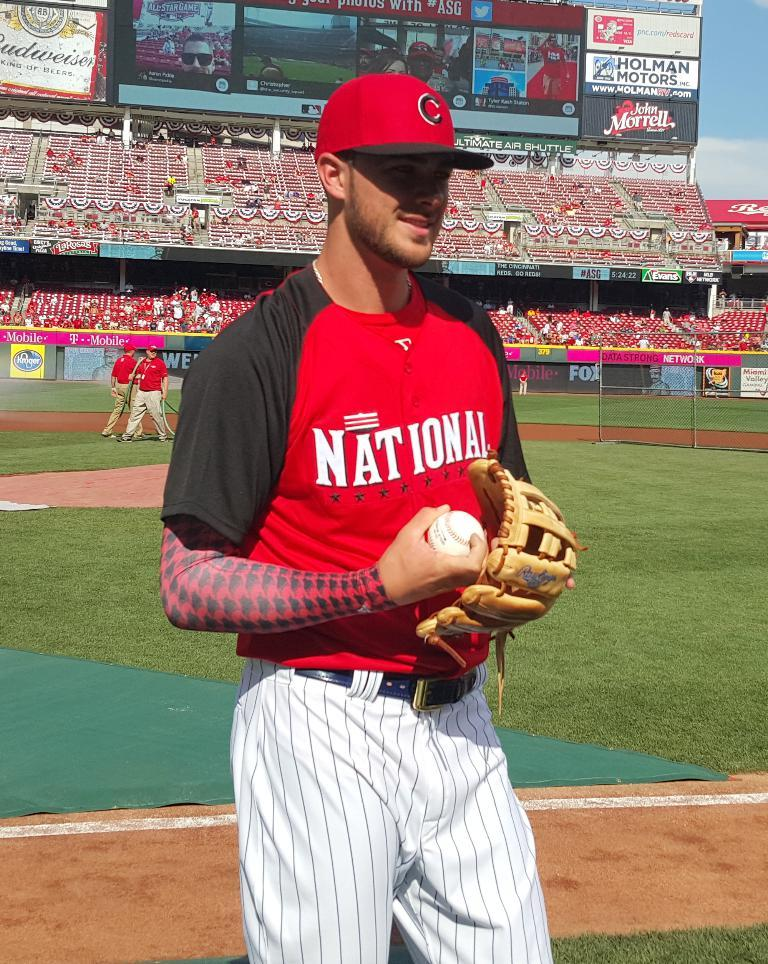<image>
Create a compact narrative representing the image presented. the name National that is on a jersey 